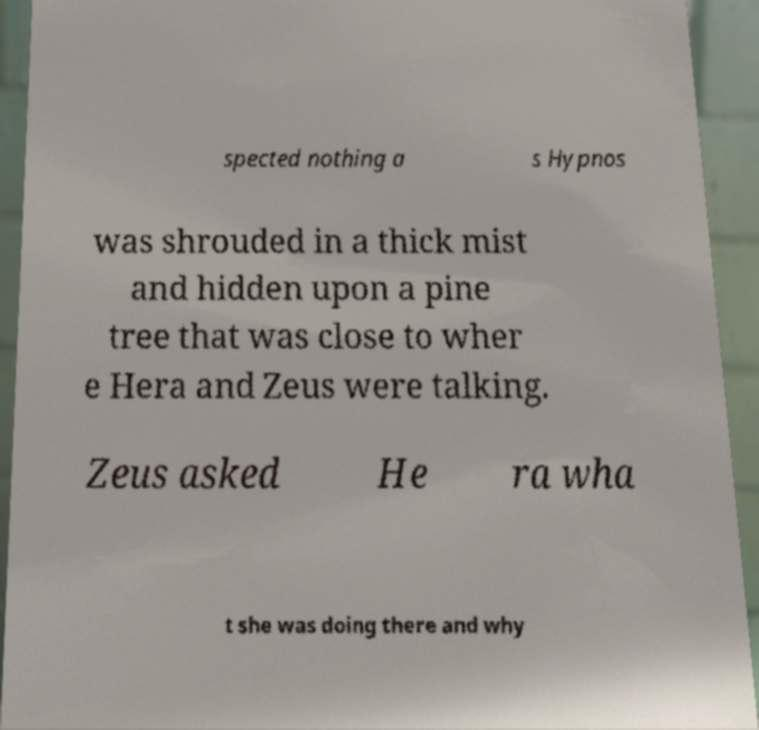Could you extract and type out the text from this image? spected nothing a s Hypnos was shrouded in a thick mist and hidden upon a pine tree that was close to wher e Hera and Zeus were talking. Zeus asked He ra wha t she was doing there and why 